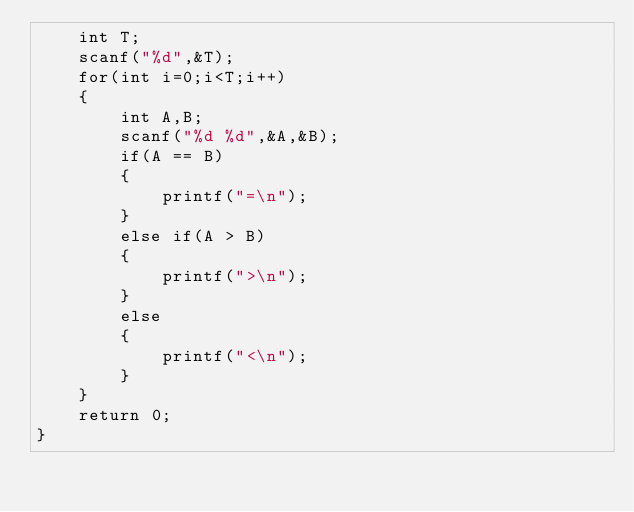<code> <loc_0><loc_0><loc_500><loc_500><_C_>    int T;
    scanf("%d",&T);
    for(int i=0;i<T;i++)
    {
        int A,B;
        scanf("%d %d",&A,&B);
        if(A == B)
        {
            printf("=\n");
        }
        else if(A > B)
        {
            printf(">\n");
        }
        else
        {
            printf("<\n");
        }
    }
    return 0;
}
</code> 